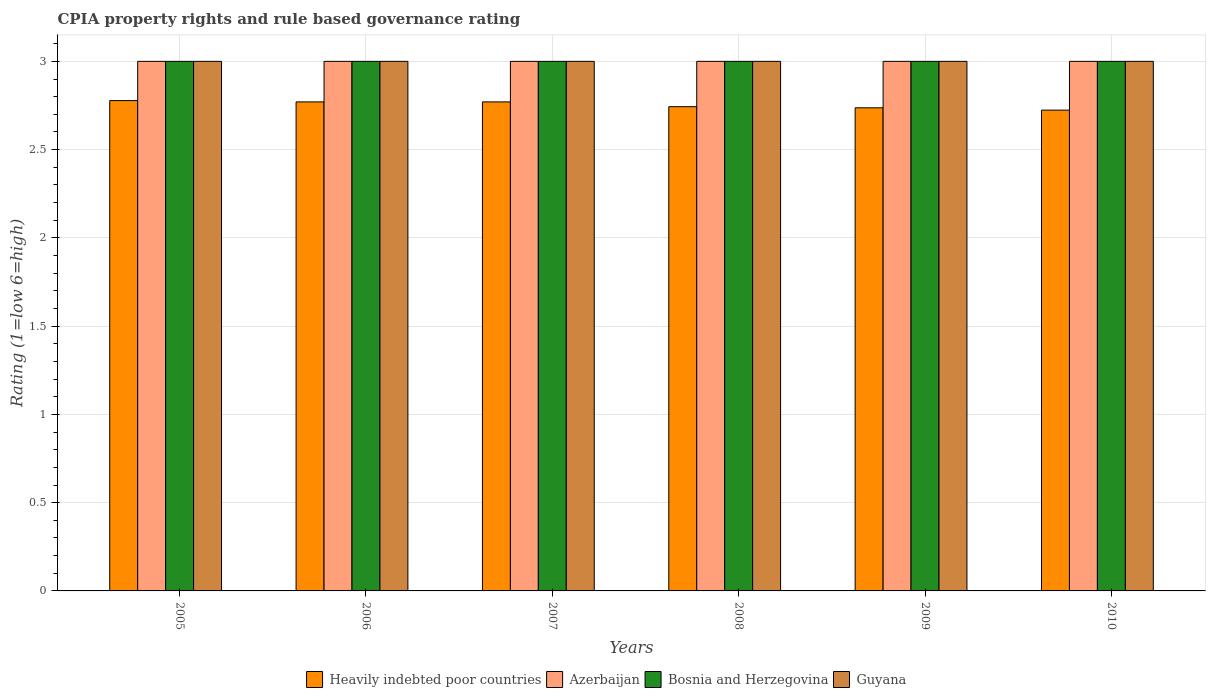How many bars are there on the 4th tick from the right?
Make the answer very short. 4. What is the CPIA rating in Guyana in 2009?
Give a very brief answer. 3. Across all years, what is the maximum CPIA rating in Heavily indebted poor countries?
Your response must be concise. 2.78. Across all years, what is the minimum CPIA rating in Heavily indebted poor countries?
Your answer should be compact. 2.72. What is the difference between the CPIA rating in Heavily indebted poor countries in 2007 and that in 2010?
Your answer should be very brief. 0.05. What is the difference between the CPIA rating in Heavily indebted poor countries in 2008 and the CPIA rating in Azerbaijan in 2006?
Your answer should be very brief. -0.26. In the year 2005, what is the difference between the CPIA rating in Azerbaijan and CPIA rating in Bosnia and Herzegovina?
Give a very brief answer. 0. In how many years, is the CPIA rating in Azerbaijan greater than 2.7?
Provide a succinct answer. 6. What is the ratio of the CPIA rating in Heavily indebted poor countries in 2009 to that in 2010?
Keep it short and to the point. 1. What is the difference between the highest and the second highest CPIA rating in Azerbaijan?
Keep it short and to the point. 0. Is it the case that in every year, the sum of the CPIA rating in Azerbaijan and CPIA rating in Heavily indebted poor countries is greater than the sum of CPIA rating in Guyana and CPIA rating in Bosnia and Herzegovina?
Your answer should be very brief. No. What does the 4th bar from the left in 2010 represents?
Provide a succinct answer. Guyana. What does the 2nd bar from the right in 2006 represents?
Make the answer very short. Bosnia and Herzegovina. Does the graph contain any zero values?
Your answer should be very brief. No. How are the legend labels stacked?
Provide a succinct answer. Horizontal. What is the title of the graph?
Make the answer very short. CPIA property rights and rule based governance rating. What is the label or title of the X-axis?
Ensure brevity in your answer.  Years. What is the label or title of the Y-axis?
Offer a very short reply. Rating (1=low 6=high). What is the Rating (1=low 6=high) in Heavily indebted poor countries in 2005?
Your answer should be compact. 2.78. What is the Rating (1=low 6=high) of Heavily indebted poor countries in 2006?
Your answer should be compact. 2.77. What is the Rating (1=low 6=high) in Azerbaijan in 2006?
Your response must be concise. 3. What is the Rating (1=low 6=high) in Heavily indebted poor countries in 2007?
Keep it short and to the point. 2.77. What is the Rating (1=low 6=high) of Heavily indebted poor countries in 2008?
Ensure brevity in your answer.  2.74. What is the Rating (1=low 6=high) in Guyana in 2008?
Give a very brief answer. 3. What is the Rating (1=low 6=high) in Heavily indebted poor countries in 2009?
Your answer should be very brief. 2.74. What is the Rating (1=low 6=high) of Azerbaijan in 2009?
Ensure brevity in your answer.  3. What is the Rating (1=low 6=high) in Heavily indebted poor countries in 2010?
Keep it short and to the point. 2.72. What is the Rating (1=low 6=high) in Azerbaijan in 2010?
Offer a terse response. 3. What is the Rating (1=low 6=high) of Bosnia and Herzegovina in 2010?
Your response must be concise. 3. What is the Rating (1=low 6=high) in Guyana in 2010?
Your response must be concise. 3. Across all years, what is the maximum Rating (1=low 6=high) of Heavily indebted poor countries?
Your answer should be very brief. 2.78. Across all years, what is the maximum Rating (1=low 6=high) in Azerbaijan?
Give a very brief answer. 3. Across all years, what is the maximum Rating (1=low 6=high) of Bosnia and Herzegovina?
Offer a very short reply. 3. Across all years, what is the minimum Rating (1=low 6=high) of Heavily indebted poor countries?
Ensure brevity in your answer.  2.72. What is the total Rating (1=low 6=high) in Heavily indebted poor countries in the graph?
Offer a terse response. 16.52. What is the total Rating (1=low 6=high) in Azerbaijan in the graph?
Your answer should be very brief. 18. What is the difference between the Rating (1=low 6=high) in Heavily indebted poor countries in 2005 and that in 2006?
Make the answer very short. 0.01. What is the difference between the Rating (1=low 6=high) in Azerbaijan in 2005 and that in 2006?
Provide a short and direct response. 0. What is the difference between the Rating (1=low 6=high) in Bosnia and Herzegovina in 2005 and that in 2006?
Offer a very short reply. 0. What is the difference between the Rating (1=low 6=high) of Guyana in 2005 and that in 2006?
Offer a terse response. 0. What is the difference between the Rating (1=low 6=high) of Heavily indebted poor countries in 2005 and that in 2007?
Your answer should be very brief. 0.01. What is the difference between the Rating (1=low 6=high) in Azerbaijan in 2005 and that in 2007?
Your response must be concise. 0. What is the difference between the Rating (1=low 6=high) in Heavily indebted poor countries in 2005 and that in 2008?
Your response must be concise. 0.03. What is the difference between the Rating (1=low 6=high) of Bosnia and Herzegovina in 2005 and that in 2008?
Give a very brief answer. 0. What is the difference between the Rating (1=low 6=high) of Heavily indebted poor countries in 2005 and that in 2009?
Give a very brief answer. 0.04. What is the difference between the Rating (1=low 6=high) of Azerbaijan in 2005 and that in 2009?
Make the answer very short. 0. What is the difference between the Rating (1=low 6=high) of Guyana in 2005 and that in 2009?
Ensure brevity in your answer.  0. What is the difference between the Rating (1=low 6=high) of Heavily indebted poor countries in 2005 and that in 2010?
Offer a very short reply. 0.05. What is the difference between the Rating (1=low 6=high) of Azerbaijan in 2005 and that in 2010?
Offer a very short reply. 0. What is the difference between the Rating (1=low 6=high) of Bosnia and Herzegovina in 2005 and that in 2010?
Give a very brief answer. 0. What is the difference between the Rating (1=low 6=high) in Heavily indebted poor countries in 2006 and that in 2007?
Keep it short and to the point. 0. What is the difference between the Rating (1=low 6=high) of Bosnia and Herzegovina in 2006 and that in 2007?
Your response must be concise. 0. What is the difference between the Rating (1=low 6=high) in Heavily indebted poor countries in 2006 and that in 2008?
Provide a short and direct response. 0.03. What is the difference between the Rating (1=low 6=high) in Guyana in 2006 and that in 2008?
Offer a very short reply. 0. What is the difference between the Rating (1=low 6=high) of Heavily indebted poor countries in 2006 and that in 2009?
Offer a terse response. 0.03. What is the difference between the Rating (1=low 6=high) of Azerbaijan in 2006 and that in 2009?
Offer a very short reply. 0. What is the difference between the Rating (1=low 6=high) of Bosnia and Herzegovina in 2006 and that in 2009?
Your response must be concise. 0. What is the difference between the Rating (1=low 6=high) in Guyana in 2006 and that in 2009?
Your answer should be compact. 0. What is the difference between the Rating (1=low 6=high) of Heavily indebted poor countries in 2006 and that in 2010?
Ensure brevity in your answer.  0.05. What is the difference between the Rating (1=low 6=high) in Azerbaijan in 2006 and that in 2010?
Ensure brevity in your answer.  0. What is the difference between the Rating (1=low 6=high) of Bosnia and Herzegovina in 2006 and that in 2010?
Provide a succinct answer. 0. What is the difference between the Rating (1=low 6=high) in Heavily indebted poor countries in 2007 and that in 2008?
Your answer should be very brief. 0.03. What is the difference between the Rating (1=low 6=high) of Bosnia and Herzegovina in 2007 and that in 2008?
Offer a very short reply. 0. What is the difference between the Rating (1=low 6=high) of Heavily indebted poor countries in 2007 and that in 2009?
Keep it short and to the point. 0.03. What is the difference between the Rating (1=low 6=high) of Azerbaijan in 2007 and that in 2009?
Provide a succinct answer. 0. What is the difference between the Rating (1=low 6=high) of Guyana in 2007 and that in 2009?
Offer a terse response. 0. What is the difference between the Rating (1=low 6=high) in Heavily indebted poor countries in 2007 and that in 2010?
Your response must be concise. 0.05. What is the difference between the Rating (1=low 6=high) in Guyana in 2007 and that in 2010?
Provide a succinct answer. 0. What is the difference between the Rating (1=low 6=high) of Heavily indebted poor countries in 2008 and that in 2009?
Make the answer very short. 0.01. What is the difference between the Rating (1=low 6=high) of Heavily indebted poor countries in 2008 and that in 2010?
Your answer should be compact. 0.02. What is the difference between the Rating (1=low 6=high) of Azerbaijan in 2008 and that in 2010?
Provide a short and direct response. 0. What is the difference between the Rating (1=low 6=high) in Bosnia and Herzegovina in 2008 and that in 2010?
Your answer should be compact. 0. What is the difference between the Rating (1=low 6=high) of Heavily indebted poor countries in 2009 and that in 2010?
Keep it short and to the point. 0.01. What is the difference between the Rating (1=low 6=high) of Azerbaijan in 2009 and that in 2010?
Offer a terse response. 0. What is the difference between the Rating (1=low 6=high) in Bosnia and Herzegovina in 2009 and that in 2010?
Offer a terse response. 0. What is the difference between the Rating (1=low 6=high) of Guyana in 2009 and that in 2010?
Offer a terse response. 0. What is the difference between the Rating (1=low 6=high) of Heavily indebted poor countries in 2005 and the Rating (1=low 6=high) of Azerbaijan in 2006?
Your answer should be very brief. -0.22. What is the difference between the Rating (1=low 6=high) of Heavily indebted poor countries in 2005 and the Rating (1=low 6=high) of Bosnia and Herzegovina in 2006?
Your answer should be compact. -0.22. What is the difference between the Rating (1=low 6=high) in Heavily indebted poor countries in 2005 and the Rating (1=low 6=high) in Guyana in 2006?
Your response must be concise. -0.22. What is the difference between the Rating (1=low 6=high) of Bosnia and Herzegovina in 2005 and the Rating (1=low 6=high) of Guyana in 2006?
Offer a terse response. 0. What is the difference between the Rating (1=low 6=high) in Heavily indebted poor countries in 2005 and the Rating (1=low 6=high) in Azerbaijan in 2007?
Your answer should be very brief. -0.22. What is the difference between the Rating (1=low 6=high) of Heavily indebted poor countries in 2005 and the Rating (1=low 6=high) of Bosnia and Herzegovina in 2007?
Make the answer very short. -0.22. What is the difference between the Rating (1=low 6=high) of Heavily indebted poor countries in 2005 and the Rating (1=low 6=high) of Guyana in 2007?
Give a very brief answer. -0.22. What is the difference between the Rating (1=low 6=high) in Azerbaijan in 2005 and the Rating (1=low 6=high) in Bosnia and Herzegovina in 2007?
Ensure brevity in your answer.  0. What is the difference between the Rating (1=low 6=high) in Heavily indebted poor countries in 2005 and the Rating (1=low 6=high) in Azerbaijan in 2008?
Your answer should be compact. -0.22. What is the difference between the Rating (1=low 6=high) of Heavily indebted poor countries in 2005 and the Rating (1=low 6=high) of Bosnia and Herzegovina in 2008?
Make the answer very short. -0.22. What is the difference between the Rating (1=low 6=high) of Heavily indebted poor countries in 2005 and the Rating (1=low 6=high) of Guyana in 2008?
Your response must be concise. -0.22. What is the difference between the Rating (1=low 6=high) in Azerbaijan in 2005 and the Rating (1=low 6=high) in Bosnia and Herzegovina in 2008?
Keep it short and to the point. 0. What is the difference between the Rating (1=low 6=high) of Heavily indebted poor countries in 2005 and the Rating (1=low 6=high) of Azerbaijan in 2009?
Your answer should be very brief. -0.22. What is the difference between the Rating (1=low 6=high) of Heavily indebted poor countries in 2005 and the Rating (1=low 6=high) of Bosnia and Herzegovina in 2009?
Provide a short and direct response. -0.22. What is the difference between the Rating (1=low 6=high) in Heavily indebted poor countries in 2005 and the Rating (1=low 6=high) in Guyana in 2009?
Offer a terse response. -0.22. What is the difference between the Rating (1=low 6=high) of Heavily indebted poor countries in 2005 and the Rating (1=low 6=high) of Azerbaijan in 2010?
Offer a very short reply. -0.22. What is the difference between the Rating (1=low 6=high) in Heavily indebted poor countries in 2005 and the Rating (1=low 6=high) in Bosnia and Herzegovina in 2010?
Provide a succinct answer. -0.22. What is the difference between the Rating (1=low 6=high) in Heavily indebted poor countries in 2005 and the Rating (1=low 6=high) in Guyana in 2010?
Offer a terse response. -0.22. What is the difference between the Rating (1=low 6=high) of Azerbaijan in 2005 and the Rating (1=low 6=high) of Bosnia and Herzegovina in 2010?
Offer a very short reply. 0. What is the difference between the Rating (1=low 6=high) of Azerbaijan in 2005 and the Rating (1=low 6=high) of Guyana in 2010?
Make the answer very short. 0. What is the difference between the Rating (1=low 6=high) in Heavily indebted poor countries in 2006 and the Rating (1=low 6=high) in Azerbaijan in 2007?
Your answer should be very brief. -0.23. What is the difference between the Rating (1=low 6=high) of Heavily indebted poor countries in 2006 and the Rating (1=low 6=high) of Bosnia and Herzegovina in 2007?
Provide a short and direct response. -0.23. What is the difference between the Rating (1=low 6=high) in Heavily indebted poor countries in 2006 and the Rating (1=low 6=high) in Guyana in 2007?
Offer a very short reply. -0.23. What is the difference between the Rating (1=low 6=high) of Azerbaijan in 2006 and the Rating (1=low 6=high) of Guyana in 2007?
Your response must be concise. 0. What is the difference between the Rating (1=low 6=high) of Bosnia and Herzegovina in 2006 and the Rating (1=low 6=high) of Guyana in 2007?
Your answer should be compact. 0. What is the difference between the Rating (1=low 6=high) in Heavily indebted poor countries in 2006 and the Rating (1=low 6=high) in Azerbaijan in 2008?
Your answer should be compact. -0.23. What is the difference between the Rating (1=low 6=high) in Heavily indebted poor countries in 2006 and the Rating (1=low 6=high) in Bosnia and Herzegovina in 2008?
Provide a succinct answer. -0.23. What is the difference between the Rating (1=low 6=high) of Heavily indebted poor countries in 2006 and the Rating (1=low 6=high) of Guyana in 2008?
Provide a succinct answer. -0.23. What is the difference between the Rating (1=low 6=high) of Azerbaijan in 2006 and the Rating (1=low 6=high) of Guyana in 2008?
Your answer should be compact. 0. What is the difference between the Rating (1=low 6=high) of Heavily indebted poor countries in 2006 and the Rating (1=low 6=high) of Azerbaijan in 2009?
Provide a short and direct response. -0.23. What is the difference between the Rating (1=low 6=high) in Heavily indebted poor countries in 2006 and the Rating (1=low 6=high) in Bosnia and Herzegovina in 2009?
Keep it short and to the point. -0.23. What is the difference between the Rating (1=low 6=high) of Heavily indebted poor countries in 2006 and the Rating (1=low 6=high) of Guyana in 2009?
Give a very brief answer. -0.23. What is the difference between the Rating (1=low 6=high) in Azerbaijan in 2006 and the Rating (1=low 6=high) in Bosnia and Herzegovina in 2009?
Make the answer very short. 0. What is the difference between the Rating (1=low 6=high) of Heavily indebted poor countries in 2006 and the Rating (1=low 6=high) of Azerbaijan in 2010?
Make the answer very short. -0.23. What is the difference between the Rating (1=low 6=high) in Heavily indebted poor countries in 2006 and the Rating (1=low 6=high) in Bosnia and Herzegovina in 2010?
Ensure brevity in your answer.  -0.23. What is the difference between the Rating (1=low 6=high) in Heavily indebted poor countries in 2006 and the Rating (1=low 6=high) in Guyana in 2010?
Your answer should be compact. -0.23. What is the difference between the Rating (1=low 6=high) of Heavily indebted poor countries in 2007 and the Rating (1=low 6=high) of Azerbaijan in 2008?
Your response must be concise. -0.23. What is the difference between the Rating (1=low 6=high) in Heavily indebted poor countries in 2007 and the Rating (1=low 6=high) in Bosnia and Herzegovina in 2008?
Give a very brief answer. -0.23. What is the difference between the Rating (1=low 6=high) of Heavily indebted poor countries in 2007 and the Rating (1=low 6=high) of Guyana in 2008?
Your response must be concise. -0.23. What is the difference between the Rating (1=low 6=high) of Heavily indebted poor countries in 2007 and the Rating (1=low 6=high) of Azerbaijan in 2009?
Your answer should be compact. -0.23. What is the difference between the Rating (1=low 6=high) of Heavily indebted poor countries in 2007 and the Rating (1=low 6=high) of Bosnia and Herzegovina in 2009?
Ensure brevity in your answer.  -0.23. What is the difference between the Rating (1=low 6=high) in Heavily indebted poor countries in 2007 and the Rating (1=low 6=high) in Guyana in 2009?
Give a very brief answer. -0.23. What is the difference between the Rating (1=low 6=high) in Bosnia and Herzegovina in 2007 and the Rating (1=low 6=high) in Guyana in 2009?
Your answer should be compact. 0. What is the difference between the Rating (1=low 6=high) of Heavily indebted poor countries in 2007 and the Rating (1=low 6=high) of Azerbaijan in 2010?
Make the answer very short. -0.23. What is the difference between the Rating (1=low 6=high) in Heavily indebted poor countries in 2007 and the Rating (1=low 6=high) in Bosnia and Herzegovina in 2010?
Your answer should be very brief. -0.23. What is the difference between the Rating (1=low 6=high) of Heavily indebted poor countries in 2007 and the Rating (1=low 6=high) of Guyana in 2010?
Your answer should be very brief. -0.23. What is the difference between the Rating (1=low 6=high) of Azerbaijan in 2007 and the Rating (1=low 6=high) of Guyana in 2010?
Your answer should be very brief. 0. What is the difference between the Rating (1=low 6=high) in Heavily indebted poor countries in 2008 and the Rating (1=low 6=high) in Azerbaijan in 2009?
Provide a succinct answer. -0.26. What is the difference between the Rating (1=low 6=high) of Heavily indebted poor countries in 2008 and the Rating (1=low 6=high) of Bosnia and Herzegovina in 2009?
Your response must be concise. -0.26. What is the difference between the Rating (1=low 6=high) of Heavily indebted poor countries in 2008 and the Rating (1=low 6=high) of Guyana in 2009?
Ensure brevity in your answer.  -0.26. What is the difference between the Rating (1=low 6=high) in Azerbaijan in 2008 and the Rating (1=low 6=high) in Bosnia and Herzegovina in 2009?
Make the answer very short. 0. What is the difference between the Rating (1=low 6=high) of Heavily indebted poor countries in 2008 and the Rating (1=low 6=high) of Azerbaijan in 2010?
Make the answer very short. -0.26. What is the difference between the Rating (1=low 6=high) in Heavily indebted poor countries in 2008 and the Rating (1=low 6=high) in Bosnia and Herzegovina in 2010?
Make the answer very short. -0.26. What is the difference between the Rating (1=low 6=high) of Heavily indebted poor countries in 2008 and the Rating (1=low 6=high) of Guyana in 2010?
Ensure brevity in your answer.  -0.26. What is the difference between the Rating (1=low 6=high) of Azerbaijan in 2008 and the Rating (1=low 6=high) of Bosnia and Herzegovina in 2010?
Keep it short and to the point. 0. What is the difference between the Rating (1=low 6=high) in Azerbaijan in 2008 and the Rating (1=low 6=high) in Guyana in 2010?
Your response must be concise. 0. What is the difference between the Rating (1=low 6=high) of Heavily indebted poor countries in 2009 and the Rating (1=low 6=high) of Azerbaijan in 2010?
Provide a succinct answer. -0.26. What is the difference between the Rating (1=low 6=high) of Heavily indebted poor countries in 2009 and the Rating (1=low 6=high) of Bosnia and Herzegovina in 2010?
Offer a terse response. -0.26. What is the difference between the Rating (1=low 6=high) in Heavily indebted poor countries in 2009 and the Rating (1=low 6=high) in Guyana in 2010?
Provide a short and direct response. -0.26. What is the difference between the Rating (1=low 6=high) of Bosnia and Herzegovina in 2009 and the Rating (1=low 6=high) of Guyana in 2010?
Provide a short and direct response. 0. What is the average Rating (1=low 6=high) of Heavily indebted poor countries per year?
Provide a succinct answer. 2.75. What is the average Rating (1=low 6=high) in Azerbaijan per year?
Keep it short and to the point. 3. What is the average Rating (1=low 6=high) of Bosnia and Herzegovina per year?
Your answer should be very brief. 3. What is the average Rating (1=low 6=high) in Guyana per year?
Offer a very short reply. 3. In the year 2005, what is the difference between the Rating (1=low 6=high) in Heavily indebted poor countries and Rating (1=low 6=high) in Azerbaijan?
Give a very brief answer. -0.22. In the year 2005, what is the difference between the Rating (1=low 6=high) in Heavily indebted poor countries and Rating (1=low 6=high) in Bosnia and Herzegovina?
Your response must be concise. -0.22. In the year 2005, what is the difference between the Rating (1=low 6=high) of Heavily indebted poor countries and Rating (1=low 6=high) of Guyana?
Ensure brevity in your answer.  -0.22. In the year 2005, what is the difference between the Rating (1=low 6=high) in Azerbaijan and Rating (1=low 6=high) in Bosnia and Herzegovina?
Offer a very short reply. 0. In the year 2005, what is the difference between the Rating (1=low 6=high) in Azerbaijan and Rating (1=low 6=high) in Guyana?
Your answer should be very brief. 0. In the year 2005, what is the difference between the Rating (1=low 6=high) of Bosnia and Herzegovina and Rating (1=low 6=high) of Guyana?
Make the answer very short. 0. In the year 2006, what is the difference between the Rating (1=low 6=high) in Heavily indebted poor countries and Rating (1=low 6=high) in Azerbaijan?
Make the answer very short. -0.23. In the year 2006, what is the difference between the Rating (1=low 6=high) of Heavily indebted poor countries and Rating (1=low 6=high) of Bosnia and Herzegovina?
Offer a very short reply. -0.23. In the year 2006, what is the difference between the Rating (1=low 6=high) of Heavily indebted poor countries and Rating (1=low 6=high) of Guyana?
Offer a very short reply. -0.23. In the year 2006, what is the difference between the Rating (1=low 6=high) of Azerbaijan and Rating (1=low 6=high) of Guyana?
Your response must be concise. 0. In the year 2007, what is the difference between the Rating (1=low 6=high) of Heavily indebted poor countries and Rating (1=low 6=high) of Azerbaijan?
Your response must be concise. -0.23. In the year 2007, what is the difference between the Rating (1=low 6=high) in Heavily indebted poor countries and Rating (1=low 6=high) in Bosnia and Herzegovina?
Keep it short and to the point. -0.23. In the year 2007, what is the difference between the Rating (1=low 6=high) of Heavily indebted poor countries and Rating (1=low 6=high) of Guyana?
Provide a succinct answer. -0.23. In the year 2008, what is the difference between the Rating (1=low 6=high) of Heavily indebted poor countries and Rating (1=low 6=high) of Azerbaijan?
Keep it short and to the point. -0.26. In the year 2008, what is the difference between the Rating (1=low 6=high) of Heavily indebted poor countries and Rating (1=low 6=high) of Bosnia and Herzegovina?
Offer a terse response. -0.26. In the year 2008, what is the difference between the Rating (1=low 6=high) in Heavily indebted poor countries and Rating (1=low 6=high) in Guyana?
Your answer should be very brief. -0.26. In the year 2008, what is the difference between the Rating (1=low 6=high) of Azerbaijan and Rating (1=low 6=high) of Guyana?
Provide a succinct answer. 0. In the year 2008, what is the difference between the Rating (1=low 6=high) of Bosnia and Herzegovina and Rating (1=low 6=high) of Guyana?
Give a very brief answer. 0. In the year 2009, what is the difference between the Rating (1=low 6=high) of Heavily indebted poor countries and Rating (1=low 6=high) of Azerbaijan?
Your answer should be compact. -0.26. In the year 2009, what is the difference between the Rating (1=low 6=high) in Heavily indebted poor countries and Rating (1=low 6=high) in Bosnia and Herzegovina?
Your answer should be very brief. -0.26. In the year 2009, what is the difference between the Rating (1=low 6=high) in Heavily indebted poor countries and Rating (1=low 6=high) in Guyana?
Offer a very short reply. -0.26. In the year 2009, what is the difference between the Rating (1=low 6=high) in Azerbaijan and Rating (1=low 6=high) in Guyana?
Keep it short and to the point. 0. In the year 2010, what is the difference between the Rating (1=low 6=high) of Heavily indebted poor countries and Rating (1=low 6=high) of Azerbaijan?
Give a very brief answer. -0.28. In the year 2010, what is the difference between the Rating (1=low 6=high) of Heavily indebted poor countries and Rating (1=low 6=high) of Bosnia and Herzegovina?
Provide a succinct answer. -0.28. In the year 2010, what is the difference between the Rating (1=low 6=high) in Heavily indebted poor countries and Rating (1=low 6=high) in Guyana?
Your response must be concise. -0.28. In the year 2010, what is the difference between the Rating (1=low 6=high) in Azerbaijan and Rating (1=low 6=high) in Guyana?
Provide a succinct answer. 0. What is the ratio of the Rating (1=low 6=high) in Azerbaijan in 2005 to that in 2006?
Make the answer very short. 1. What is the ratio of the Rating (1=low 6=high) in Bosnia and Herzegovina in 2005 to that in 2006?
Your answer should be very brief. 1. What is the ratio of the Rating (1=low 6=high) in Guyana in 2005 to that in 2006?
Keep it short and to the point. 1. What is the ratio of the Rating (1=low 6=high) of Bosnia and Herzegovina in 2005 to that in 2007?
Your answer should be compact. 1. What is the ratio of the Rating (1=low 6=high) of Heavily indebted poor countries in 2005 to that in 2008?
Your answer should be compact. 1.01. What is the ratio of the Rating (1=low 6=high) in Azerbaijan in 2005 to that in 2008?
Your answer should be very brief. 1. What is the ratio of the Rating (1=low 6=high) of Bosnia and Herzegovina in 2005 to that in 2008?
Give a very brief answer. 1. What is the ratio of the Rating (1=low 6=high) in Heavily indebted poor countries in 2005 to that in 2009?
Make the answer very short. 1.01. What is the ratio of the Rating (1=low 6=high) of Azerbaijan in 2005 to that in 2009?
Provide a succinct answer. 1. What is the ratio of the Rating (1=low 6=high) of Bosnia and Herzegovina in 2005 to that in 2009?
Provide a succinct answer. 1. What is the ratio of the Rating (1=low 6=high) of Guyana in 2005 to that in 2009?
Ensure brevity in your answer.  1. What is the ratio of the Rating (1=low 6=high) of Heavily indebted poor countries in 2005 to that in 2010?
Keep it short and to the point. 1.02. What is the ratio of the Rating (1=low 6=high) in Azerbaijan in 2005 to that in 2010?
Provide a succinct answer. 1. What is the ratio of the Rating (1=low 6=high) in Bosnia and Herzegovina in 2005 to that in 2010?
Provide a succinct answer. 1. What is the ratio of the Rating (1=low 6=high) in Azerbaijan in 2006 to that in 2007?
Offer a very short reply. 1. What is the ratio of the Rating (1=low 6=high) of Guyana in 2006 to that in 2007?
Your answer should be compact. 1. What is the ratio of the Rating (1=low 6=high) of Heavily indebted poor countries in 2006 to that in 2008?
Provide a short and direct response. 1.01. What is the ratio of the Rating (1=low 6=high) of Bosnia and Herzegovina in 2006 to that in 2008?
Ensure brevity in your answer.  1. What is the ratio of the Rating (1=low 6=high) in Heavily indebted poor countries in 2006 to that in 2009?
Your response must be concise. 1.01. What is the ratio of the Rating (1=low 6=high) in Azerbaijan in 2006 to that in 2009?
Give a very brief answer. 1. What is the ratio of the Rating (1=low 6=high) in Heavily indebted poor countries in 2006 to that in 2010?
Give a very brief answer. 1.02. What is the ratio of the Rating (1=low 6=high) of Azerbaijan in 2006 to that in 2010?
Your answer should be very brief. 1. What is the ratio of the Rating (1=low 6=high) in Bosnia and Herzegovina in 2006 to that in 2010?
Your answer should be compact. 1. What is the ratio of the Rating (1=low 6=high) in Guyana in 2006 to that in 2010?
Your response must be concise. 1. What is the ratio of the Rating (1=low 6=high) of Heavily indebted poor countries in 2007 to that in 2008?
Offer a very short reply. 1.01. What is the ratio of the Rating (1=low 6=high) of Heavily indebted poor countries in 2007 to that in 2009?
Provide a succinct answer. 1.01. What is the ratio of the Rating (1=low 6=high) of Guyana in 2007 to that in 2009?
Give a very brief answer. 1. What is the ratio of the Rating (1=low 6=high) of Heavily indebted poor countries in 2007 to that in 2010?
Offer a terse response. 1.02. What is the ratio of the Rating (1=low 6=high) of Bosnia and Herzegovina in 2007 to that in 2010?
Offer a very short reply. 1. What is the ratio of the Rating (1=low 6=high) of Guyana in 2007 to that in 2010?
Your answer should be very brief. 1. What is the ratio of the Rating (1=low 6=high) of Guyana in 2008 to that in 2009?
Your response must be concise. 1. What is the ratio of the Rating (1=low 6=high) of Guyana in 2008 to that in 2010?
Provide a succinct answer. 1. What is the ratio of the Rating (1=low 6=high) in Heavily indebted poor countries in 2009 to that in 2010?
Provide a short and direct response. 1. What is the ratio of the Rating (1=low 6=high) of Bosnia and Herzegovina in 2009 to that in 2010?
Your answer should be compact. 1. What is the difference between the highest and the second highest Rating (1=low 6=high) of Heavily indebted poor countries?
Give a very brief answer. 0.01. What is the difference between the highest and the lowest Rating (1=low 6=high) of Heavily indebted poor countries?
Your answer should be compact. 0.05. What is the difference between the highest and the lowest Rating (1=low 6=high) of Azerbaijan?
Make the answer very short. 0. What is the difference between the highest and the lowest Rating (1=low 6=high) in Bosnia and Herzegovina?
Offer a very short reply. 0. 